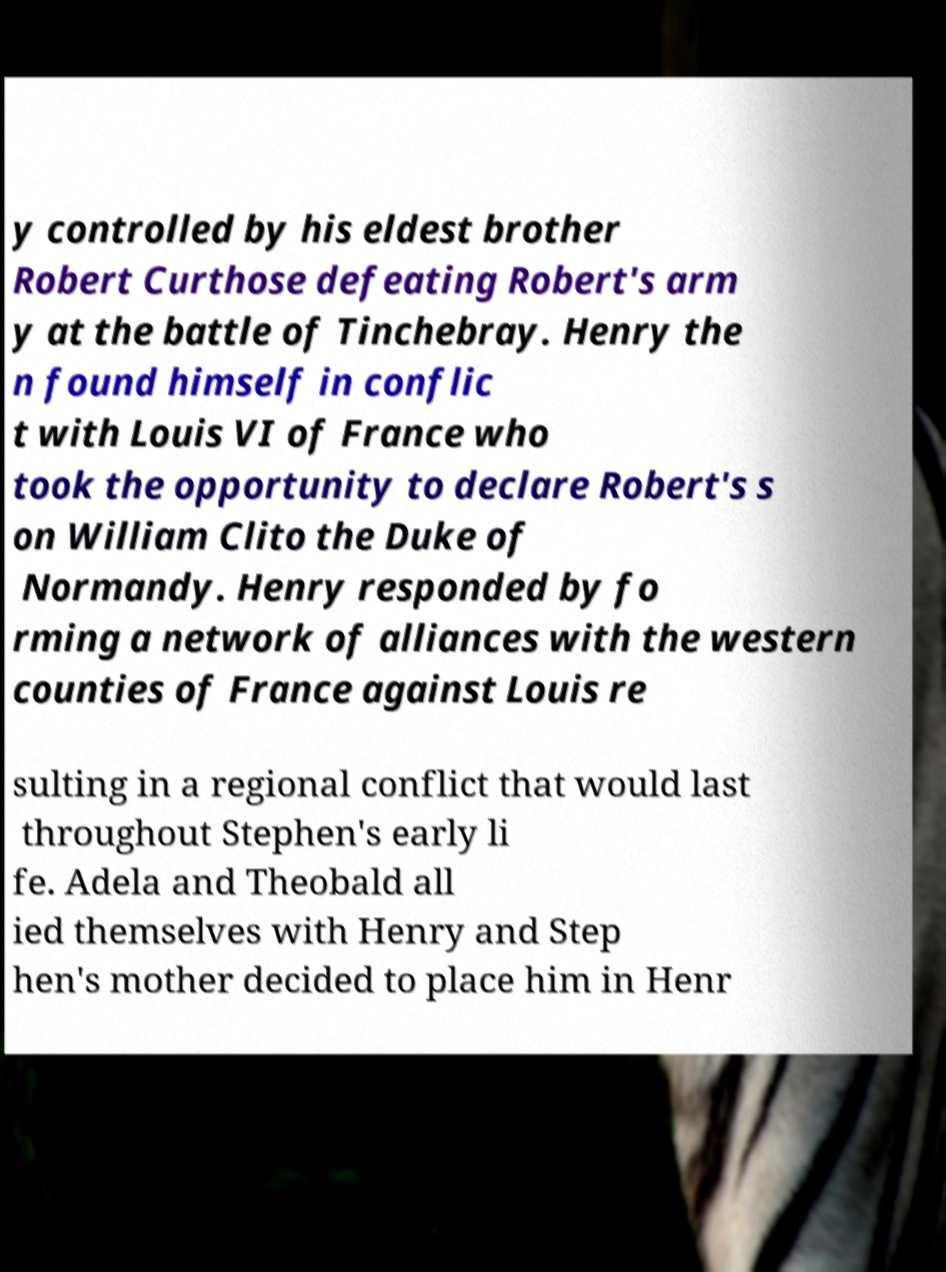What messages or text are displayed in this image? I need them in a readable, typed format. y controlled by his eldest brother Robert Curthose defeating Robert's arm y at the battle of Tinchebray. Henry the n found himself in conflic t with Louis VI of France who took the opportunity to declare Robert's s on William Clito the Duke of Normandy. Henry responded by fo rming a network of alliances with the western counties of France against Louis re sulting in a regional conflict that would last throughout Stephen's early li fe. Adela and Theobald all ied themselves with Henry and Step hen's mother decided to place him in Henr 